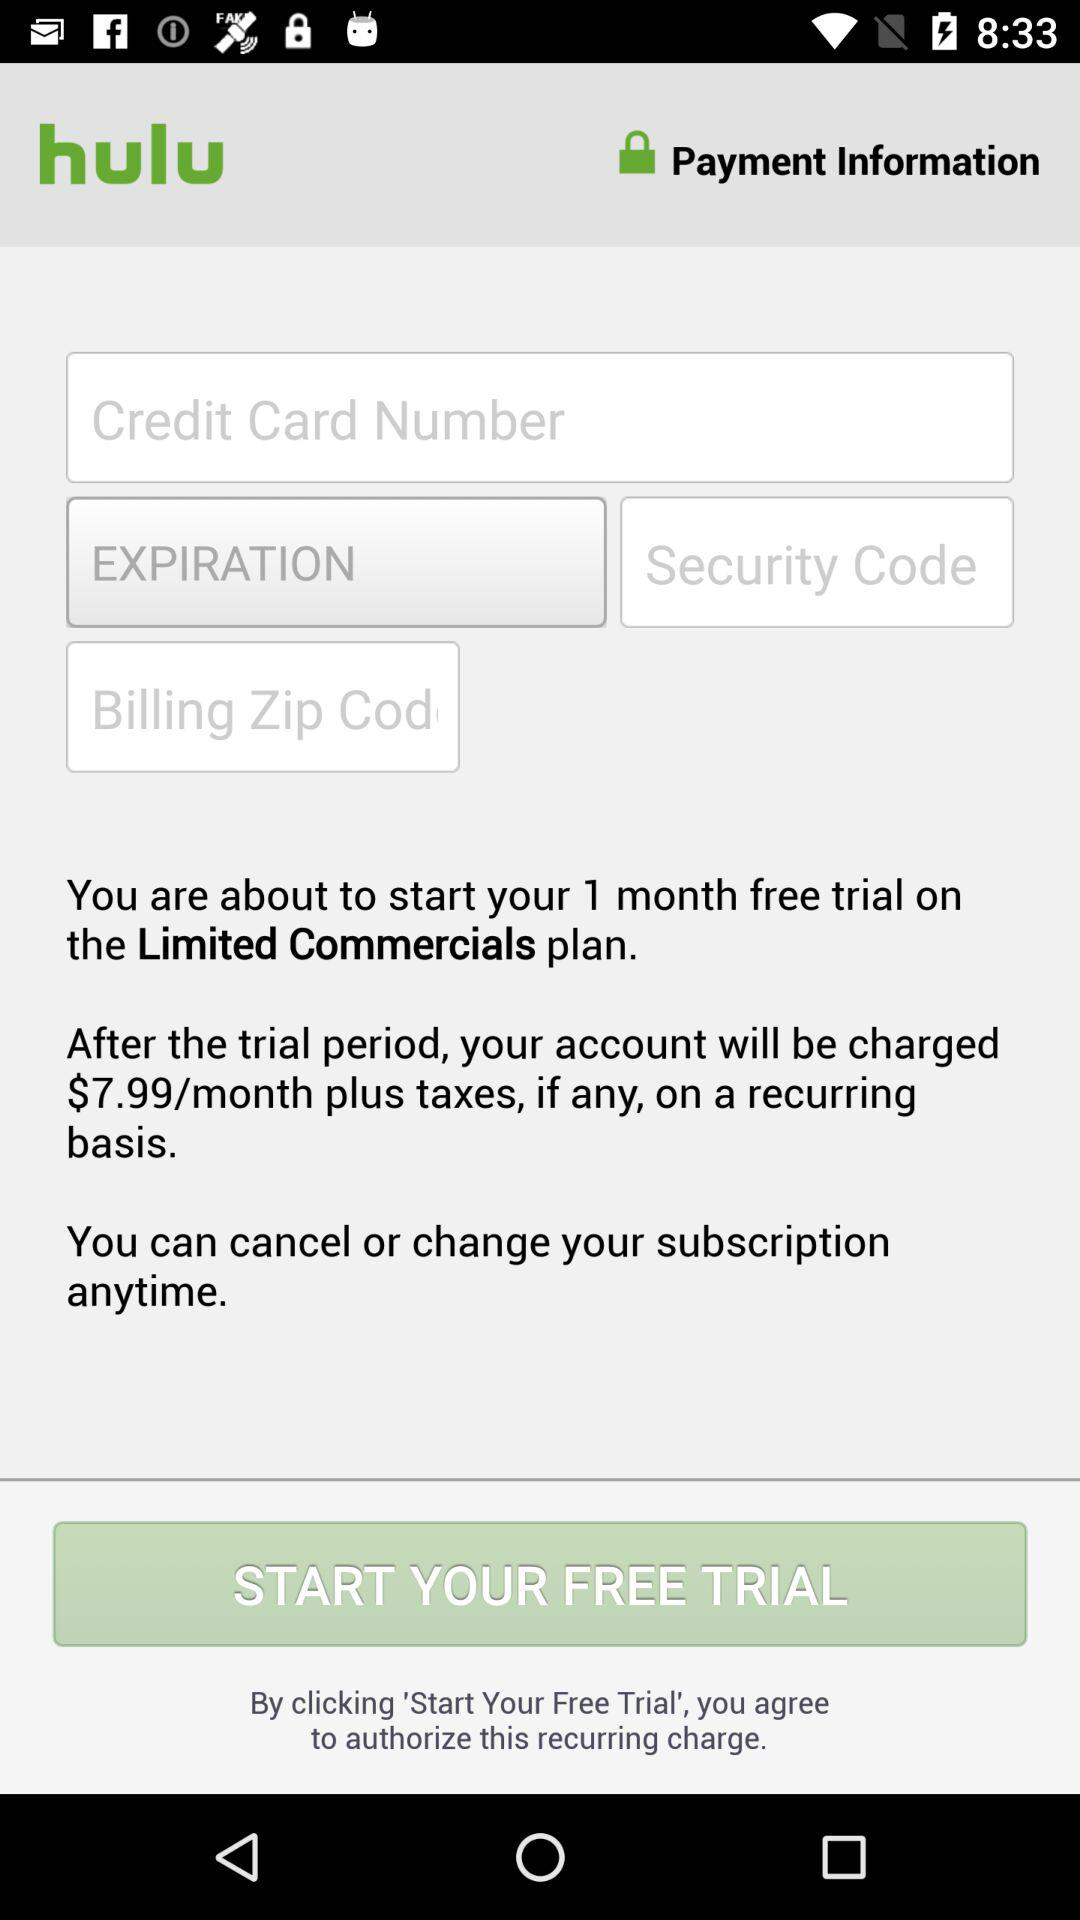How many input fields are there for the billing information?
Answer the question using a single word or phrase. 3 